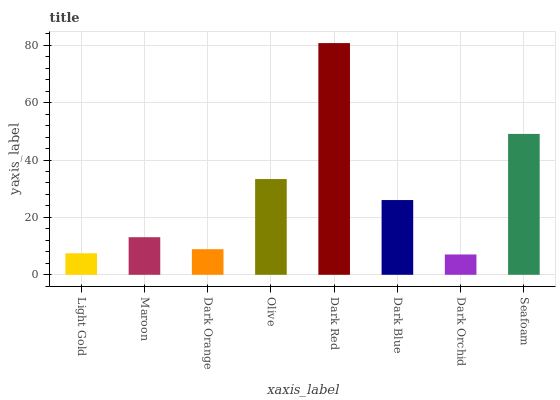Is Dark Orchid the minimum?
Answer yes or no. Yes. Is Dark Red the maximum?
Answer yes or no. Yes. Is Maroon the minimum?
Answer yes or no. No. Is Maroon the maximum?
Answer yes or no. No. Is Maroon greater than Light Gold?
Answer yes or no. Yes. Is Light Gold less than Maroon?
Answer yes or no. Yes. Is Light Gold greater than Maroon?
Answer yes or no. No. Is Maroon less than Light Gold?
Answer yes or no. No. Is Dark Blue the high median?
Answer yes or no. Yes. Is Maroon the low median?
Answer yes or no. Yes. Is Dark Orange the high median?
Answer yes or no. No. Is Dark Orange the low median?
Answer yes or no. No. 